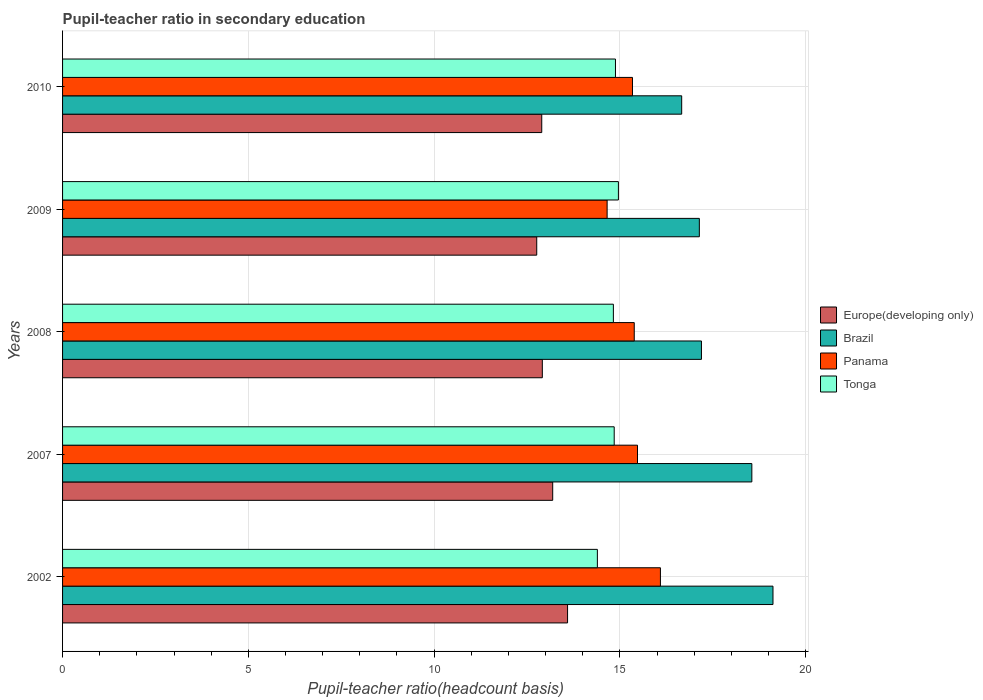How many different coloured bars are there?
Give a very brief answer. 4. Are the number of bars per tick equal to the number of legend labels?
Your answer should be very brief. Yes. How many bars are there on the 5th tick from the top?
Ensure brevity in your answer.  4. What is the label of the 5th group of bars from the top?
Ensure brevity in your answer.  2002. In how many cases, is the number of bars for a given year not equal to the number of legend labels?
Give a very brief answer. 0. What is the pupil-teacher ratio in secondary education in Tonga in 2002?
Give a very brief answer. 14.39. Across all years, what is the maximum pupil-teacher ratio in secondary education in Panama?
Your answer should be very brief. 16.09. Across all years, what is the minimum pupil-teacher ratio in secondary education in Brazil?
Provide a succinct answer. 16.66. In which year was the pupil-teacher ratio in secondary education in Europe(developing only) minimum?
Give a very brief answer. 2009. What is the total pupil-teacher ratio in secondary education in Tonga in the graph?
Your answer should be compact. 73.91. What is the difference between the pupil-teacher ratio in secondary education in Brazil in 2007 and that in 2009?
Provide a short and direct response. 1.41. What is the difference between the pupil-teacher ratio in secondary education in Tonga in 2010 and the pupil-teacher ratio in secondary education in Europe(developing only) in 2002?
Ensure brevity in your answer.  1.29. What is the average pupil-teacher ratio in secondary education in Europe(developing only) per year?
Your answer should be very brief. 13.07. In the year 2007, what is the difference between the pupil-teacher ratio in secondary education in Tonga and pupil-teacher ratio in secondary education in Panama?
Your answer should be very brief. -0.63. In how many years, is the pupil-teacher ratio in secondary education in Panama greater than 13 ?
Make the answer very short. 5. What is the ratio of the pupil-teacher ratio in secondary education in Europe(developing only) in 2008 to that in 2010?
Make the answer very short. 1. What is the difference between the highest and the second highest pupil-teacher ratio in secondary education in Tonga?
Your answer should be compact. 0.08. What is the difference between the highest and the lowest pupil-teacher ratio in secondary education in Europe(developing only)?
Offer a terse response. 0.83. In how many years, is the pupil-teacher ratio in secondary education in Tonga greater than the average pupil-teacher ratio in secondary education in Tonga taken over all years?
Your response must be concise. 4. Is it the case that in every year, the sum of the pupil-teacher ratio in secondary education in Tonga and pupil-teacher ratio in secondary education in Panama is greater than the sum of pupil-teacher ratio in secondary education in Europe(developing only) and pupil-teacher ratio in secondary education in Brazil?
Make the answer very short. No. What does the 1st bar from the top in 2010 represents?
Offer a terse response. Tonga. What does the 3rd bar from the bottom in 2002 represents?
Provide a succinct answer. Panama. Is it the case that in every year, the sum of the pupil-teacher ratio in secondary education in Brazil and pupil-teacher ratio in secondary education in Europe(developing only) is greater than the pupil-teacher ratio in secondary education in Tonga?
Your response must be concise. Yes. Are all the bars in the graph horizontal?
Provide a short and direct response. Yes. How many years are there in the graph?
Keep it short and to the point. 5. What is the difference between two consecutive major ticks on the X-axis?
Your answer should be compact. 5. Are the values on the major ticks of X-axis written in scientific E-notation?
Keep it short and to the point. No. Does the graph contain grids?
Make the answer very short. Yes. Where does the legend appear in the graph?
Provide a succinct answer. Center right. How many legend labels are there?
Give a very brief answer. 4. How are the legend labels stacked?
Keep it short and to the point. Vertical. What is the title of the graph?
Offer a terse response. Pupil-teacher ratio in secondary education. What is the label or title of the X-axis?
Ensure brevity in your answer.  Pupil-teacher ratio(headcount basis). What is the label or title of the Y-axis?
Provide a short and direct response. Years. What is the Pupil-teacher ratio(headcount basis) of Europe(developing only) in 2002?
Give a very brief answer. 13.59. What is the Pupil-teacher ratio(headcount basis) in Brazil in 2002?
Give a very brief answer. 19.12. What is the Pupil-teacher ratio(headcount basis) in Panama in 2002?
Ensure brevity in your answer.  16.09. What is the Pupil-teacher ratio(headcount basis) in Tonga in 2002?
Provide a short and direct response. 14.39. What is the Pupil-teacher ratio(headcount basis) in Europe(developing only) in 2007?
Your answer should be compact. 13.19. What is the Pupil-teacher ratio(headcount basis) in Brazil in 2007?
Offer a terse response. 18.55. What is the Pupil-teacher ratio(headcount basis) of Panama in 2007?
Provide a succinct answer. 15.47. What is the Pupil-teacher ratio(headcount basis) of Tonga in 2007?
Give a very brief answer. 14.85. What is the Pupil-teacher ratio(headcount basis) in Europe(developing only) in 2008?
Offer a terse response. 12.91. What is the Pupil-teacher ratio(headcount basis) in Brazil in 2008?
Your response must be concise. 17.2. What is the Pupil-teacher ratio(headcount basis) of Panama in 2008?
Ensure brevity in your answer.  15.39. What is the Pupil-teacher ratio(headcount basis) in Tonga in 2008?
Provide a short and direct response. 14.82. What is the Pupil-teacher ratio(headcount basis) in Europe(developing only) in 2009?
Provide a short and direct response. 12.76. What is the Pupil-teacher ratio(headcount basis) of Brazil in 2009?
Your response must be concise. 17.14. What is the Pupil-teacher ratio(headcount basis) of Panama in 2009?
Offer a terse response. 14.66. What is the Pupil-teacher ratio(headcount basis) of Tonga in 2009?
Offer a terse response. 14.96. What is the Pupil-teacher ratio(headcount basis) of Europe(developing only) in 2010?
Your response must be concise. 12.9. What is the Pupil-teacher ratio(headcount basis) in Brazil in 2010?
Provide a succinct answer. 16.66. What is the Pupil-teacher ratio(headcount basis) of Panama in 2010?
Provide a short and direct response. 15.34. What is the Pupil-teacher ratio(headcount basis) of Tonga in 2010?
Offer a very short reply. 14.88. Across all years, what is the maximum Pupil-teacher ratio(headcount basis) of Europe(developing only)?
Your response must be concise. 13.59. Across all years, what is the maximum Pupil-teacher ratio(headcount basis) of Brazil?
Ensure brevity in your answer.  19.12. Across all years, what is the maximum Pupil-teacher ratio(headcount basis) in Panama?
Your answer should be very brief. 16.09. Across all years, what is the maximum Pupil-teacher ratio(headcount basis) in Tonga?
Your answer should be very brief. 14.96. Across all years, what is the minimum Pupil-teacher ratio(headcount basis) of Europe(developing only)?
Your response must be concise. 12.76. Across all years, what is the minimum Pupil-teacher ratio(headcount basis) in Brazil?
Make the answer very short. 16.66. Across all years, what is the minimum Pupil-teacher ratio(headcount basis) in Panama?
Offer a terse response. 14.66. Across all years, what is the minimum Pupil-teacher ratio(headcount basis) in Tonga?
Your answer should be very brief. 14.39. What is the total Pupil-teacher ratio(headcount basis) of Europe(developing only) in the graph?
Make the answer very short. 65.36. What is the total Pupil-teacher ratio(headcount basis) of Brazil in the graph?
Your answer should be very brief. 88.67. What is the total Pupil-teacher ratio(headcount basis) in Panama in the graph?
Provide a short and direct response. 76.95. What is the total Pupil-teacher ratio(headcount basis) in Tonga in the graph?
Your response must be concise. 73.91. What is the difference between the Pupil-teacher ratio(headcount basis) in Europe(developing only) in 2002 and that in 2007?
Ensure brevity in your answer.  0.4. What is the difference between the Pupil-teacher ratio(headcount basis) of Brazil in 2002 and that in 2007?
Your answer should be compact. 0.57. What is the difference between the Pupil-teacher ratio(headcount basis) in Panama in 2002 and that in 2007?
Keep it short and to the point. 0.62. What is the difference between the Pupil-teacher ratio(headcount basis) of Tonga in 2002 and that in 2007?
Offer a very short reply. -0.45. What is the difference between the Pupil-teacher ratio(headcount basis) in Europe(developing only) in 2002 and that in 2008?
Your answer should be very brief. 0.68. What is the difference between the Pupil-teacher ratio(headcount basis) in Brazil in 2002 and that in 2008?
Provide a succinct answer. 1.93. What is the difference between the Pupil-teacher ratio(headcount basis) of Panama in 2002 and that in 2008?
Make the answer very short. 0.7. What is the difference between the Pupil-teacher ratio(headcount basis) of Tonga in 2002 and that in 2008?
Your response must be concise. -0.43. What is the difference between the Pupil-teacher ratio(headcount basis) of Europe(developing only) in 2002 and that in 2009?
Keep it short and to the point. 0.83. What is the difference between the Pupil-teacher ratio(headcount basis) in Brazil in 2002 and that in 2009?
Offer a very short reply. 1.98. What is the difference between the Pupil-teacher ratio(headcount basis) of Panama in 2002 and that in 2009?
Your answer should be very brief. 1.43. What is the difference between the Pupil-teacher ratio(headcount basis) in Tonga in 2002 and that in 2009?
Ensure brevity in your answer.  -0.57. What is the difference between the Pupil-teacher ratio(headcount basis) of Europe(developing only) in 2002 and that in 2010?
Your response must be concise. 0.69. What is the difference between the Pupil-teacher ratio(headcount basis) of Brazil in 2002 and that in 2010?
Your response must be concise. 2.46. What is the difference between the Pupil-teacher ratio(headcount basis) in Panama in 2002 and that in 2010?
Your response must be concise. 0.75. What is the difference between the Pupil-teacher ratio(headcount basis) of Tonga in 2002 and that in 2010?
Offer a very short reply. -0.49. What is the difference between the Pupil-teacher ratio(headcount basis) of Europe(developing only) in 2007 and that in 2008?
Make the answer very short. 0.28. What is the difference between the Pupil-teacher ratio(headcount basis) in Brazil in 2007 and that in 2008?
Your answer should be very brief. 1.36. What is the difference between the Pupil-teacher ratio(headcount basis) in Panama in 2007 and that in 2008?
Provide a succinct answer. 0.09. What is the difference between the Pupil-teacher ratio(headcount basis) in Tonga in 2007 and that in 2008?
Offer a terse response. 0.02. What is the difference between the Pupil-teacher ratio(headcount basis) in Europe(developing only) in 2007 and that in 2009?
Give a very brief answer. 0.43. What is the difference between the Pupil-teacher ratio(headcount basis) of Brazil in 2007 and that in 2009?
Make the answer very short. 1.41. What is the difference between the Pupil-teacher ratio(headcount basis) of Panama in 2007 and that in 2009?
Give a very brief answer. 0.82. What is the difference between the Pupil-teacher ratio(headcount basis) of Tonga in 2007 and that in 2009?
Provide a short and direct response. -0.11. What is the difference between the Pupil-teacher ratio(headcount basis) of Europe(developing only) in 2007 and that in 2010?
Your answer should be very brief. 0.29. What is the difference between the Pupil-teacher ratio(headcount basis) of Brazil in 2007 and that in 2010?
Your answer should be compact. 1.89. What is the difference between the Pupil-teacher ratio(headcount basis) of Panama in 2007 and that in 2010?
Give a very brief answer. 0.14. What is the difference between the Pupil-teacher ratio(headcount basis) of Tonga in 2007 and that in 2010?
Your answer should be very brief. -0.03. What is the difference between the Pupil-teacher ratio(headcount basis) of Europe(developing only) in 2008 and that in 2009?
Make the answer very short. 0.15. What is the difference between the Pupil-teacher ratio(headcount basis) of Brazil in 2008 and that in 2009?
Provide a short and direct response. 0.06. What is the difference between the Pupil-teacher ratio(headcount basis) of Panama in 2008 and that in 2009?
Your response must be concise. 0.73. What is the difference between the Pupil-teacher ratio(headcount basis) in Tonga in 2008 and that in 2009?
Give a very brief answer. -0.14. What is the difference between the Pupil-teacher ratio(headcount basis) of Europe(developing only) in 2008 and that in 2010?
Keep it short and to the point. 0.02. What is the difference between the Pupil-teacher ratio(headcount basis) of Brazil in 2008 and that in 2010?
Your answer should be very brief. 0.53. What is the difference between the Pupil-teacher ratio(headcount basis) in Panama in 2008 and that in 2010?
Provide a succinct answer. 0.05. What is the difference between the Pupil-teacher ratio(headcount basis) of Tonga in 2008 and that in 2010?
Offer a terse response. -0.06. What is the difference between the Pupil-teacher ratio(headcount basis) of Europe(developing only) in 2009 and that in 2010?
Provide a succinct answer. -0.14. What is the difference between the Pupil-teacher ratio(headcount basis) in Brazil in 2009 and that in 2010?
Ensure brevity in your answer.  0.47. What is the difference between the Pupil-teacher ratio(headcount basis) in Panama in 2009 and that in 2010?
Give a very brief answer. -0.68. What is the difference between the Pupil-teacher ratio(headcount basis) of Tonga in 2009 and that in 2010?
Your answer should be compact. 0.08. What is the difference between the Pupil-teacher ratio(headcount basis) in Europe(developing only) in 2002 and the Pupil-teacher ratio(headcount basis) in Brazil in 2007?
Offer a very short reply. -4.96. What is the difference between the Pupil-teacher ratio(headcount basis) in Europe(developing only) in 2002 and the Pupil-teacher ratio(headcount basis) in Panama in 2007?
Offer a terse response. -1.88. What is the difference between the Pupil-teacher ratio(headcount basis) in Europe(developing only) in 2002 and the Pupil-teacher ratio(headcount basis) in Tonga in 2007?
Provide a succinct answer. -1.26. What is the difference between the Pupil-teacher ratio(headcount basis) in Brazil in 2002 and the Pupil-teacher ratio(headcount basis) in Panama in 2007?
Give a very brief answer. 3.65. What is the difference between the Pupil-teacher ratio(headcount basis) in Brazil in 2002 and the Pupil-teacher ratio(headcount basis) in Tonga in 2007?
Offer a very short reply. 4.27. What is the difference between the Pupil-teacher ratio(headcount basis) in Panama in 2002 and the Pupil-teacher ratio(headcount basis) in Tonga in 2007?
Give a very brief answer. 1.24. What is the difference between the Pupil-teacher ratio(headcount basis) of Europe(developing only) in 2002 and the Pupil-teacher ratio(headcount basis) of Brazil in 2008?
Provide a short and direct response. -3.6. What is the difference between the Pupil-teacher ratio(headcount basis) of Europe(developing only) in 2002 and the Pupil-teacher ratio(headcount basis) of Panama in 2008?
Keep it short and to the point. -1.79. What is the difference between the Pupil-teacher ratio(headcount basis) in Europe(developing only) in 2002 and the Pupil-teacher ratio(headcount basis) in Tonga in 2008?
Offer a very short reply. -1.23. What is the difference between the Pupil-teacher ratio(headcount basis) in Brazil in 2002 and the Pupil-teacher ratio(headcount basis) in Panama in 2008?
Give a very brief answer. 3.73. What is the difference between the Pupil-teacher ratio(headcount basis) of Brazil in 2002 and the Pupil-teacher ratio(headcount basis) of Tonga in 2008?
Provide a short and direct response. 4.3. What is the difference between the Pupil-teacher ratio(headcount basis) in Panama in 2002 and the Pupil-teacher ratio(headcount basis) in Tonga in 2008?
Provide a succinct answer. 1.27. What is the difference between the Pupil-teacher ratio(headcount basis) in Europe(developing only) in 2002 and the Pupil-teacher ratio(headcount basis) in Brazil in 2009?
Provide a short and direct response. -3.55. What is the difference between the Pupil-teacher ratio(headcount basis) of Europe(developing only) in 2002 and the Pupil-teacher ratio(headcount basis) of Panama in 2009?
Provide a succinct answer. -1.06. What is the difference between the Pupil-teacher ratio(headcount basis) in Europe(developing only) in 2002 and the Pupil-teacher ratio(headcount basis) in Tonga in 2009?
Your answer should be compact. -1.37. What is the difference between the Pupil-teacher ratio(headcount basis) of Brazil in 2002 and the Pupil-teacher ratio(headcount basis) of Panama in 2009?
Offer a terse response. 4.46. What is the difference between the Pupil-teacher ratio(headcount basis) in Brazil in 2002 and the Pupil-teacher ratio(headcount basis) in Tonga in 2009?
Provide a short and direct response. 4.16. What is the difference between the Pupil-teacher ratio(headcount basis) in Panama in 2002 and the Pupil-teacher ratio(headcount basis) in Tonga in 2009?
Your answer should be very brief. 1.13. What is the difference between the Pupil-teacher ratio(headcount basis) in Europe(developing only) in 2002 and the Pupil-teacher ratio(headcount basis) in Brazil in 2010?
Ensure brevity in your answer.  -3.07. What is the difference between the Pupil-teacher ratio(headcount basis) in Europe(developing only) in 2002 and the Pupil-teacher ratio(headcount basis) in Panama in 2010?
Provide a succinct answer. -1.75. What is the difference between the Pupil-teacher ratio(headcount basis) in Europe(developing only) in 2002 and the Pupil-teacher ratio(headcount basis) in Tonga in 2010?
Your response must be concise. -1.29. What is the difference between the Pupil-teacher ratio(headcount basis) of Brazil in 2002 and the Pupil-teacher ratio(headcount basis) of Panama in 2010?
Your answer should be compact. 3.78. What is the difference between the Pupil-teacher ratio(headcount basis) of Brazil in 2002 and the Pupil-teacher ratio(headcount basis) of Tonga in 2010?
Ensure brevity in your answer.  4.24. What is the difference between the Pupil-teacher ratio(headcount basis) of Panama in 2002 and the Pupil-teacher ratio(headcount basis) of Tonga in 2010?
Provide a short and direct response. 1.21. What is the difference between the Pupil-teacher ratio(headcount basis) of Europe(developing only) in 2007 and the Pupil-teacher ratio(headcount basis) of Brazil in 2008?
Offer a very short reply. -4. What is the difference between the Pupil-teacher ratio(headcount basis) in Europe(developing only) in 2007 and the Pupil-teacher ratio(headcount basis) in Panama in 2008?
Make the answer very short. -2.19. What is the difference between the Pupil-teacher ratio(headcount basis) in Europe(developing only) in 2007 and the Pupil-teacher ratio(headcount basis) in Tonga in 2008?
Provide a short and direct response. -1.63. What is the difference between the Pupil-teacher ratio(headcount basis) of Brazil in 2007 and the Pupil-teacher ratio(headcount basis) of Panama in 2008?
Give a very brief answer. 3.16. What is the difference between the Pupil-teacher ratio(headcount basis) of Brazil in 2007 and the Pupil-teacher ratio(headcount basis) of Tonga in 2008?
Keep it short and to the point. 3.73. What is the difference between the Pupil-teacher ratio(headcount basis) in Panama in 2007 and the Pupil-teacher ratio(headcount basis) in Tonga in 2008?
Your response must be concise. 0.65. What is the difference between the Pupil-teacher ratio(headcount basis) of Europe(developing only) in 2007 and the Pupil-teacher ratio(headcount basis) of Brazil in 2009?
Your answer should be very brief. -3.95. What is the difference between the Pupil-teacher ratio(headcount basis) in Europe(developing only) in 2007 and the Pupil-teacher ratio(headcount basis) in Panama in 2009?
Provide a succinct answer. -1.46. What is the difference between the Pupil-teacher ratio(headcount basis) of Europe(developing only) in 2007 and the Pupil-teacher ratio(headcount basis) of Tonga in 2009?
Your answer should be very brief. -1.77. What is the difference between the Pupil-teacher ratio(headcount basis) of Brazil in 2007 and the Pupil-teacher ratio(headcount basis) of Panama in 2009?
Your answer should be very brief. 3.9. What is the difference between the Pupil-teacher ratio(headcount basis) in Brazil in 2007 and the Pupil-teacher ratio(headcount basis) in Tonga in 2009?
Your response must be concise. 3.59. What is the difference between the Pupil-teacher ratio(headcount basis) of Panama in 2007 and the Pupil-teacher ratio(headcount basis) of Tonga in 2009?
Your answer should be very brief. 0.51. What is the difference between the Pupil-teacher ratio(headcount basis) in Europe(developing only) in 2007 and the Pupil-teacher ratio(headcount basis) in Brazil in 2010?
Make the answer very short. -3.47. What is the difference between the Pupil-teacher ratio(headcount basis) of Europe(developing only) in 2007 and the Pupil-teacher ratio(headcount basis) of Panama in 2010?
Your answer should be very brief. -2.15. What is the difference between the Pupil-teacher ratio(headcount basis) in Europe(developing only) in 2007 and the Pupil-teacher ratio(headcount basis) in Tonga in 2010?
Give a very brief answer. -1.69. What is the difference between the Pupil-teacher ratio(headcount basis) in Brazil in 2007 and the Pupil-teacher ratio(headcount basis) in Panama in 2010?
Give a very brief answer. 3.21. What is the difference between the Pupil-teacher ratio(headcount basis) of Brazil in 2007 and the Pupil-teacher ratio(headcount basis) of Tonga in 2010?
Ensure brevity in your answer.  3.67. What is the difference between the Pupil-teacher ratio(headcount basis) in Panama in 2007 and the Pupil-teacher ratio(headcount basis) in Tonga in 2010?
Provide a succinct answer. 0.59. What is the difference between the Pupil-teacher ratio(headcount basis) in Europe(developing only) in 2008 and the Pupil-teacher ratio(headcount basis) in Brazil in 2009?
Ensure brevity in your answer.  -4.23. What is the difference between the Pupil-teacher ratio(headcount basis) in Europe(developing only) in 2008 and the Pupil-teacher ratio(headcount basis) in Panama in 2009?
Provide a short and direct response. -1.74. What is the difference between the Pupil-teacher ratio(headcount basis) in Europe(developing only) in 2008 and the Pupil-teacher ratio(headcount basis) in Tonga in 2009?
Offer a terse response. -2.05. What is the difference between the Pupil-teacher ratio(headcount basis) in Brazil in 2008 and the Pupil-teacher ratio(headcount basis) in Panama in 2009?
Make the answer very short. 2.54. What is the difference between the Pupil-teacher ratio(headcount basis) of Brazil in 2008 and the Pupil-teacher ratio(headcount basis) of Tonga in 2009?
Make the answer very short. 2.24. What is the difference between the Pupil-teacher ratio(headcount basis) in Panama in 2008 and the Pupil-teacher ratio(headcount basis) in Tonga in 2009?
Offer a terse response. 0.43. What is the difference between the Pupil-teacher ratio(headcount basis) of Europe(developing only) in 2008 and the Pupil-teacher ratio(headcount basis) of Brazil in 2010?
Offer a very short reply. -3.75. What is the difference between the Pupil-teacher ratio(headcount basis) of Europe(developing only) in 2008 and the Pupil-teacher ratio(headcount basis) of Panama in 2010?
Your answer should be compact. -2.43. What is the difference between the Pupil-teacher ratio(headcount basis) in Europe(developing only) in 2008 and the Pupil-teacher ratio(headcount basis) in Tonga in 2010?
Provide a short and direct response. -1.97. What is the difference between the Pupil-teacher ratio(headcount basis) in Brazil in 2008 and the Pupil-teacher ratio(headcount basis) in Panama in 2010?
Provide a short and direct response. 1.86. What is the difference between the Pupil-teacher ratio(headcount basis) of Brazil in 2008 and the Pupil-teacher ratio(headcount basis) of Tonga in 2010?
Provide a short and direct response. 2.31. What is the difference between the Pupil-teacher ratio(headcount basis) of Panama in 2008 and the Pupil-teacher ratio(headcount basis) of Tonga in 2010?
Provide a succinct answer. 0.51. What is the difference between the Pupil-teacher ratio(headcount basis) in Europe(developing only) in 2009 and the Pupil-teacher ratio(headcount basis) in Brazil in 2010?
Keep it short and to the point. -3.9. What is the difference between the Pupil-teacher ratio(headcount basis) in Europe(developing only) in 2009 and the Pupil-teacher ratio(headcount basis) in Panama in 2010?
Provide a short and direct response. -2.58. What is the difference between the Pupil-teacher ratio(headcount basis) in Europe(developing only) in 2009 and the Pupil-teacher ratio(headcount basis) in Tonga in 2010?
Provide a short and direct response. -2.12. What is the difference between the Pupil-teacher ratio(headcount basis) in Brazil in 2009 and the Pupil-teacher ratio(headcount basis) in Panama in 2010?
Your response must be concise. 1.8. What is the difference between the Pupil-teacher ratio(headcount basis) in Brazil in 2009 and the Pupil-teacher ratio(headcount basis) in Tonga in 2010?
Your response must be concise. 2.26. What is the difference between the Pupil-teacher ratio(headcount basis) in Panama in 2009 and the Pupil-teacher ratio(headcount basis) in Tonga in 2010?
Provide a short and direct response. -0.22. What is the average Pupil-teacher ratio(headcount basis) of Europe(developing only) per year?
Offer a very short reply. 13.07. What is the average Pupil-teacher ratio(headcount basis) of Brazil per year?
Offer a terse response. 17.73. What is the average Pupil-teacher ratio(headcount basis) of Panama per year?
Ensure brevity in your answer.  15.39. What is the average Pupil-teacher ratio(headcount basis) in Tonga per year?
Provide a short and direct response. 14.78. In the year 2002, what is the difference between the Pupil-teacher ratio(headcount basis) in Europe(developing only) and Pupil-teacher ratio(headcount basis) in Brazil?
Provide a succinct answer. -5.53. In the year 2002, what is the difference between the Pupil-teacher ratio(headcount basis) of Europe(developing only) and Pupil-teacher ratio(headcount basis) of Panama?
Give a very brief answer. -2.5. In the year 2002, what is the difference between the Pupil-teacher ratio(headcount basis) of Europe(developing only) and Pupil-teacher ratio(headcount basis) of Tonga?
Give a very brief answer. -0.8. In the year 2002, what is the difference between the Pupil-teacher ratio(headcount basis) of Brazil and Pupil-teacher ratio(headcount basis) of Panama?
Offer a very short reply. 3.03. In the year 2002, what is the difference between the Pupil-teacher ratio(headcount basis) in Brazil and Pupil-teacher ratio(headcount basis) in Tonga?
Your answer should be compact. 4.73. In the year 2002, what is the difference between the Pupil-teacher ratio(headcount basis) in Panama and Pupil-teacher ratio(headcount basis) in Tonga?
Provide a short and direct response. 1.7. In the year 2007, what is the difference between the Pupil-teacher ratio(headcount basis) of Europe(developing only) and Pupil-teacher ratio(headcount basis) of Brazil?
Your answer should be compact. -5.36. In the year 2007, what is the difference between the Pupil-teacher ratio(headcount basis) of Europe(developing only) and Pupil-teacher ratio(headcount basis) of Panama?
Provide a short and direct response. -2.28. In the year 2007, what is the difference between the Pupil-teacher ratio(headcount basis) in Europe(developing only) and Pupil-teacher ratio(headcount basis) in Tonga?
Keep it short and to the point. -1.66. In the year 2007, what is the difference between the Pupil-teacher ratio(headcount basis) of Brazil and Pupil-teacher ratio(headcount basis) of Panama?
Ensure brevity in your answer.  3.08. In the year 2007, what is the difference between the Pupil-teacher ratio(headcount basis) of Brazil and Pupil-teacher ratio(headcount basis) of Tonga?
Give a very brief answer. 3.7. In the year 2007, what is the difference between the Pupil-teacher ratio(headcount basis) of Panama and Pupil-teacher ratio(headcount basis) of Tonga?
Provide a short and direct response. 0.63. In the year 2008, what is the difference between the Pupil-teacher ratio(headcount basis) of Europe(developing only) and Pupil-teacher ratio(headcount basis) of Brazil?
Make the answer very short. -4.28. In the year 2008, what is the difference between the Pupil-teacher ratio(headcount basis) in Europe(developing only) and Pupil-teacher ratio(headcount basis) in Panama?
Offer a very short reply. -2.47. In the year 2008, what is the difference between the Pupil-teacher ratio(headcount basis) of Europe(developing only) and Pupil-teacher ratio(headcount basis) of Tonga?
Your answer should be very brief. -1.91. In the year 2008, what is the difference between the Pupil-teacher ratio(headcount basis) in Brazil and Pupil-teacher ratio(headcount basis) in Panama?
Your answer should be compact. 1.81. In the year 2008, what is the difference between the Pupil-teacher ratio(headcount basis) of Brazil and Pupil-teacher ratio(headcount basis) of Tonga?
Give a very brief answer. 2.37. In the year 2008, what is the difference between the Pupil-teacher ratio(headcount basis) in Panama and Pupil-teacher ratio(headcount basis) in Tonga?
Ensure brevity in your answer.  0.56. In the year 2009, what is the difference between the Pupil-teacher ratio(headcount basis) in Europe(developing only) and Pupil-teacher ratio(headcount basis) in Brazil?
Your answer should be compact. -4.38. In the year 2009, what is the difference between the Pupil-teacher ratio(headcount basis) of Europe(developing only) and Pupil-teacher ratio(headcount basis) of Panama?
Make the answer very short. -1.89. In the year 2009, what is the difference between the Pupil-teacher ratio(headcount basis) of Europe(developing only) and Pupil-teacher ratio(headcount basis) of Tonga?
Offer a terse response. -2.2. In the year 2009, what is the difference between the Pupil-teacher ratio(headcount basis) in Brazil and Pupil-teacher ratio(headcount basis) in Panama?
Your answer should be very brief. 2.48. In the year 2009, what is the difference between the Pupil-teacher ratio(headcount basis) of Brazil and Pupil-teacher ratio(headcount basis) of Tonga?
Give a very brief answer. 2.18. In the year 2009, what is the difference between the Pupil-teacher ratio(headcount basis) of Panama and Pupil-teacher ratio(headcount basis) of Tonga?
Your response must be concise. -0.3. In the year 2010, what is the difference between the Pupil-teacher ratio(headcount basis) of Europe(developing only) and Pupil-teacher ratio(headcount basis) of Brazil?
Your response must be concise. -3.77. In the year 2010, what is the difference between the Pupil-teacher ratio(headcount basis) in Europe(developing only) and Pupil-teacher ratio(headcount basis) in Panama?
Keep it short and to the point. -2.44. In the year 2010, what is the difference between the Pupil-teacher ratio(headcount basis) of Europe(developing only) and Pupil-teacher ratio(headcount basis) of Tonga?
Make the answer very short. -1.98. In the year 2010, what is the difference between the Pupil-teacher ratio(headcount basis) of Brazil and Pupil-teacher ratio(headcount basis) of Panama?
Your response must be concise. 1.32. In the year 2010, what is the difference between the Pupil-teacher ratio(headcount basis) in Brazil and Pupil-teacher ratio(headcount basis) in Tonga?
Ensure brevity in your answer.  1.78. In the year 2010, what is the difference between the Pupil-teacher ratio(headcount basis) in Panama and Pupil-teacher ratio(headcount basis) in Tonga?
Offer a very short reply. 0.46. What is the ratio of the Pupil-teacher ratio(headcount basis) of Europe(developing only) in 2002 to that in 2007?
Offer a terse response. 1.03. What is the ratio of the Pupil-teacher ratio(headcount basis) of Brazil in 2002 to that in 2007?
Offer a very short reply. 1.03. What is the ratio of the Pupil-teacher ratio(headcount basis) of Panama in 2002 to that in 2007?
Your answer should be compact. 1.04. What is the ratio of the Pupil-teacher ratio(headcount basis) in Tonga in 2002 to that in 2007?
Your answer should be very brief. 0.97. What is the ratio of the Pupil-teacher ratio(headcount basis) of Europe(developing only) in 2002 to that in 2008?
Provide a succinct answer. 1.05. What is the ratio of the Pupil-teacher ratio(headcount basis) in Brazil in 2002 to that in 2008?
Ensure brevity in your answer.  1.11. What is the ratio of the Pupil-teacher ratio(headcount basis) of Panama in 2002 to that in 2008?
Offer a terse response. 1.05. What is the ratio of the Pupil-teacher ratio(headcount basis) in Tonga in 2002 to that in 2008?
Your answer should be very brief. 0.97. What is the ratio of the Pupil-teacher ratio(headcount basis) in Europe(developing only) in 2002 to that in 2009?
Keep it short and to the point. 1.06. What is the ratio of the Pupil-teacher ratio(headcount basis) of Brazil in 2002 to that in 2009?
Provide a succinct answer. 1.12. What is the ratio of the Pupil-teacher ratio(headcount basis) in Panama in 2002 to that in 2009?
Give a very brief answer. 1.1. What is the ratio of the Pupil-teacher ratio(headcount basis) of Tonga in 2002 to that in 2009?
Provide a succinct answer. 0.96. What is the ratio of the Pupil-teacher ratio(headcount basis) in Europe(developing only) in 2002 to that in 2010?
Provide a succinct answer. 1.05. What is the ratio of the Pupil-teacher ratio(headcount basis) in Brazil in 2002 to that in 2010?
Offer a very short reply. 1.15. What is the ratio of the Pupil-teacher ratio(headcount basis) of Panama in 2002 to that in 2010?
Keep it short and to the point. 1.05. What is the ratio of the Pupil-teacher ratio(headcount basis) in Tonga in 2002 to that in 2010?
Your answer should be compact. 0.97. What is the ratio of the Pupil-teacher ratio(headcount basis) in Europe(developing only) in 2007 to that in 2008?
Offer a terse response. 1.02. What is the ratio of the Pupil-teacher ratio(headcount basis) in Brazil in 2007 to that in 2008?
Give a very brief answer. 1.08. What is the ratio of the Pupil-teacher ratio(headcount basis) of Panama in 2007 to that in 2008?
Provide a short and direct response. 1.01. What is the ratio of the Pupil-teacher ratio(headcount basis) of Europe(developing only) in 2007 to that in 2009?
Offer a terse response. 1.03. What is the ratio of the Pupil-teacher ratio(headcount basis) of Brazil in 2007 to that in 2009?
Offer a very short reply. 1.08. What is the ratio of the Pupil-teacher ratio(headcount basis) of Panama in 2007 to that in 2009?
Your answer should be compact. 1.06. What is the ratio of the Pupil-teacher ratio(headcount basis) of Europe(developing only) in 2007 to that in 2010?
Provide a short and direct response. 1.02. What is the ratio of the Pupil-teacher ratio(headcount basis) in Brazil in 2007 to that in 2010?
Ensure brevity in your answer.  1.11. What is the ratio of the Pupil-teacher ratio(headcount basis) in Panama in 2007 to that in 2010?
Make the answer very short. 1.01. What is the ratio of the Pupil-teacher ratio(headcount basis) of Europe(developing only) in 2008 to that in 2009?
Offer a terse response. 1.01. What is the ratio of the Pupil-teacher ratio(headcount basis) in Panama in 2008 to that in 2009?
Ensure brevity in your answer.  1.05. What is the ratio of the Pupil-teacher ratio(headcount basis) in Tonga in 2008 to that in 2009?
Provide a short and direct response. 0.99. What is the ratio of the Pupil-teacher ratio(headcount basis) in Europe(developing only) in 2008 to that in 2010?
Make the answer very short. 1. What is the ratio of the Pupil-teacher ratio(headcount basis) of Brazil in 2008 to that in 2010?
Ensure brevity in your answer.  1.03. What is the ratio of the Pupil-teacher ratio(headcount basis) in Brazil in 2009 to that in 2010?
Make the answer very short. 1.03. What is the ratio of the Pupil-teacher ratio(headcount basis) in Panama in 2009 to that in 2010?
Provide a succinct answer. 0.96. What is the ratio of the Pupil-teacher ratio(headcount basis) of Tonga in 2009 to that in 2010?
Your answer should be very brief. 1.01. What is the difference between the highest and the second highest Pupil-teacher ratio(headcount basis) in Europe(developing only)?
Offer a very short reply. 0.4. What is the difference between the highest and the second highest Pupil-teacher ratio(headcount basis) in Brazil?
Give a very brief answer. 0.57. What is the difference between the highest and the second highest Pupil-teacher ratio(headcount basis) in Panama?
Offer a terse response. 0.62. What is the difference between the highest and the second highest Pupil-teacher ratio(headcount basis) of Tonga?
Offer a terse response. 0.08. What is the difference between the highest and the lowest Pupil-teacher ratio(headcount basis) of Europe(developing only)?
Offer a very short reply. 0.83. What is the difference between the highest and the lowest Pupil-teacher ratio(headcount basis) of Brazil?
Offer a very short reply. 2.46. What is the difference between the highest and the lowest Pupil-teacher ratio(headcount basis) of Panama?
Give a very brief answer. 1.43. What is the difference between the highest and the lowest Pupil-teacher ratio(headcount basis) in Tonga?
Ensure brevity in your answer.  0.57. 